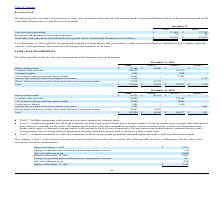According to Monolithic Power Systems's financial document, What does the table provide? a reconciliation of cash, cash equivalents and restricted cash reported on the Consolidated Balance Sheets to the amounts reported on the Consolidated Statements of Cash Flows. The document states: "ents Restricted Cash The following table provides a reconciliation of cash, cash equivalents and restricted cash reported on the Consolidated Balance ..." Also, What does restricted cash include? included a security deposit that is set aside in a bank account and cannot be withdrawn by the Company under the terms of a lease agreement. The document states: "As of December 31, 2019 and 2018, restricted cash included a security deposit that is set aside in a bank account and cannot be withdrawn by the Compa..." Also, What is the amount spent on cash and cash equivalents in 2019 and 2018 respectively? The document shows two values: 172,960 and 172,704 (in thousands). From the document: "Cash and cash equivalents $ 172,960 $ 172,704 Cash and cash equivalents $ 172,960 $ 172,704..." Also, can you calculate: What was the percentage change in Cash and cash equivalents from 2018 to 2019? To answer this question, I need to perform calculations using the financial data. The calculation is: (172,960-172,704)/172,704, which equals 0.15 (percentage). This is based on the information: "Cash and cash equivalents $ 172,960 $ 172,704 Cash and cash equivalents $ 172,960 $ 172,704..." The key data points involved are: 172,704, 172,960. Also, For how many years was the amount of total cash, cash equivalents and restricted cash reported on the Consolidated Statements of Cash Flows more than 150,000 thousand? Counting the relevant items in the document: 172,818, 173,076, I find 2 instances. The key data points involved are: 172,818, 173,076. Also, can you calculate: What was the change in Restricted cash included in other long-term assets from 2018 to 2019? Based on the calculation: 116-114 , the result is 2 (in thousands). This is based on the information: "icted cash included in other long-term assets 116 114 estricted cash included in other long-term assets 116 114..." The key data points involved are: 114, 116. 